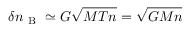Convert formula to latex. <formula><loc_0><loc_0><loc_500><loc_500>\delta n _ { B } \simeq G \sqrt { M T n } = \sqrt { G M n }</formula> 